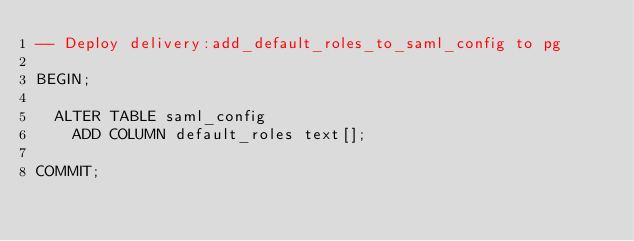<code> <loc_0><loc_0><loc_500><loc_500><_SQL_>-- Deploy delivery:add_default_roles_to_saml_config to pg

BEGIN;

  ALTER TABLE saml_config
    ADD COLUMN default_roles text[];

COMMIT;
</code> 